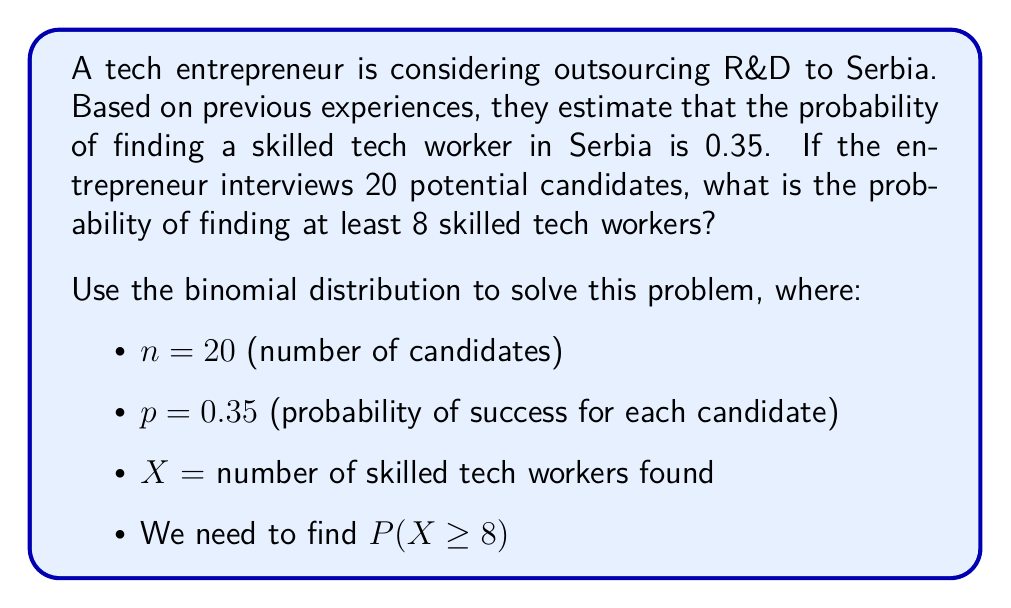Could you help me with this problem? To solve this problem, we'll use the binomial distribution and the cumulative probability concept.

1) The probability of finding at least 8 skilled workers is equal to 1 minus the probability of finding 7 or fewer skilled workers:

   $P(X \geq 8) = 1 - P(X \leq 7)$

2) We can calculate $P(X \leq 7)$ using the cumulative binomial probability function:

   $P(X \leq 7) = \sum_{k=0}^{7} \binom{20}{k} (0.35)^k (1-0.35)^{20-k}$

3) Using a calculator or statistical software to compute this sum:

   $P(X \leq 7) \approx 0.3183$

4) Therefore:

   $P(X \geq 8) = 1 - P(X \leq 7) = 1 - 0.3183 = 0.6817$

5) We can also verify this result using the complementary cumulative binomial probability function:

   $P(X \geq 8) = \sum_{k=8}^{20} \binom{20}{k} (0.35)^k (1-0.35)^{20-k} \approx 0.6817$

Thus, the probability of finding at least 8 skilled tech workers out of 20 candidates in Serbia is approximately 0.6817 or 68.17%.
Answer: 0.6817 (or 68.17%) 